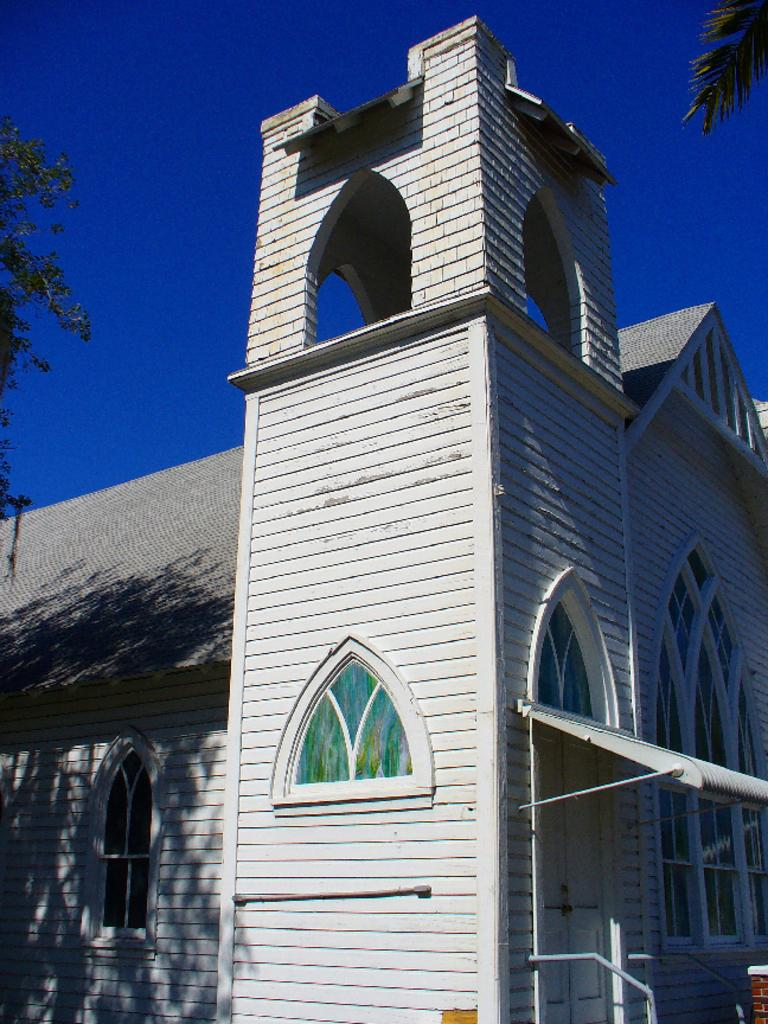What type of structure is present in the image? There is a building with windows in the image. What can be seen on either side of the building? There are trees on both sides of the building. What is the color of the sky in the background of the image? The blue sky is visible in the background of the image. How many basketballs can be seen hanging from the trees in the image? There are no basketballs present in the image; it features a building with windows and trees on both sides. 